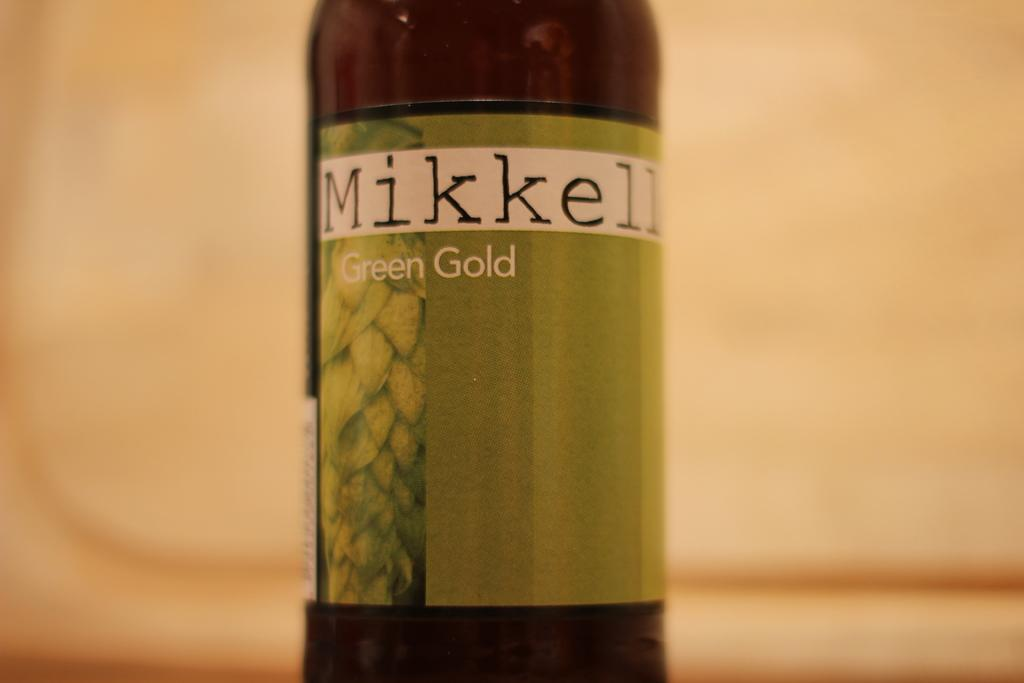<image>
Provide a brief description of the given image. A bottle of Mikkell green gold features a green label. 